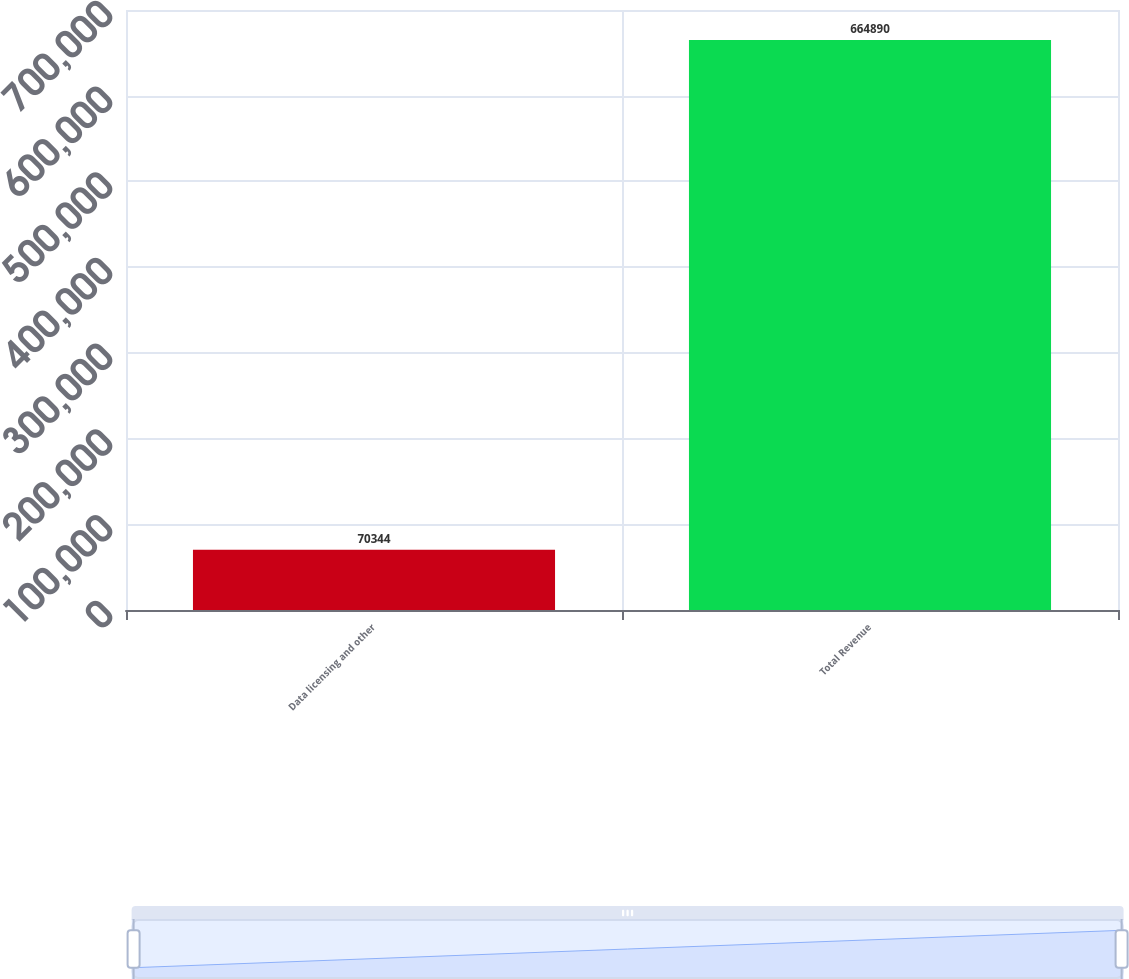<chart> <loc_0><loc_0><loc_500><loc_500><bar_chart><fcel>Data licensing and other<fcel>Total Revenue<nl><fcel>70344<fcel>664890<nl></chart> 